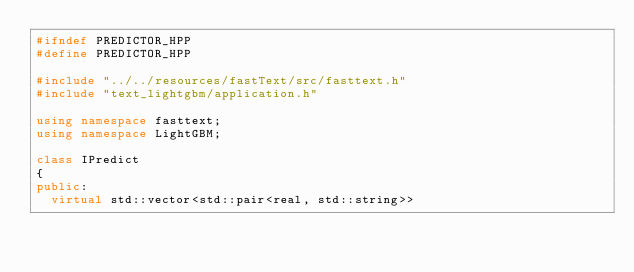<code> <loc_0><loc_0><loc_500><loc_500><_C++_>#ifndef PREDICTOR_HPP
#define PREDICTOR_HPP

#include "../../resources/fastText/src/fasttext.h"
#include "text_lightgbm/application.h"

using namespace fasttext;
using namespace LightGBM;

class IPredict
{
public:
  virtual std::vector<std::pair<real, std::string>></code> 